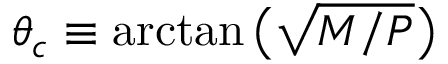<formula> <loc_0><loc_0><loc_500><loc_500>\theta _ { c } \equiv \arctan \left ( \sqrt { M / P } \right )</formula> 